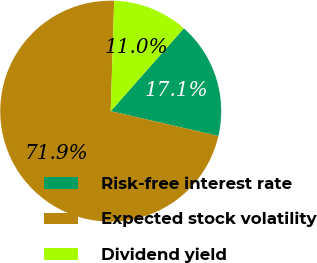<chart> <loc_0><loc_0><loc_500><loc_500><pie_chart><fcel>Risk-free interest rate<fcel>Expected stock volatility<fcel>Dividend yield<nl><fcel>17.1%<fcel>71.89%<fcel>11.01%<nl></chart> 